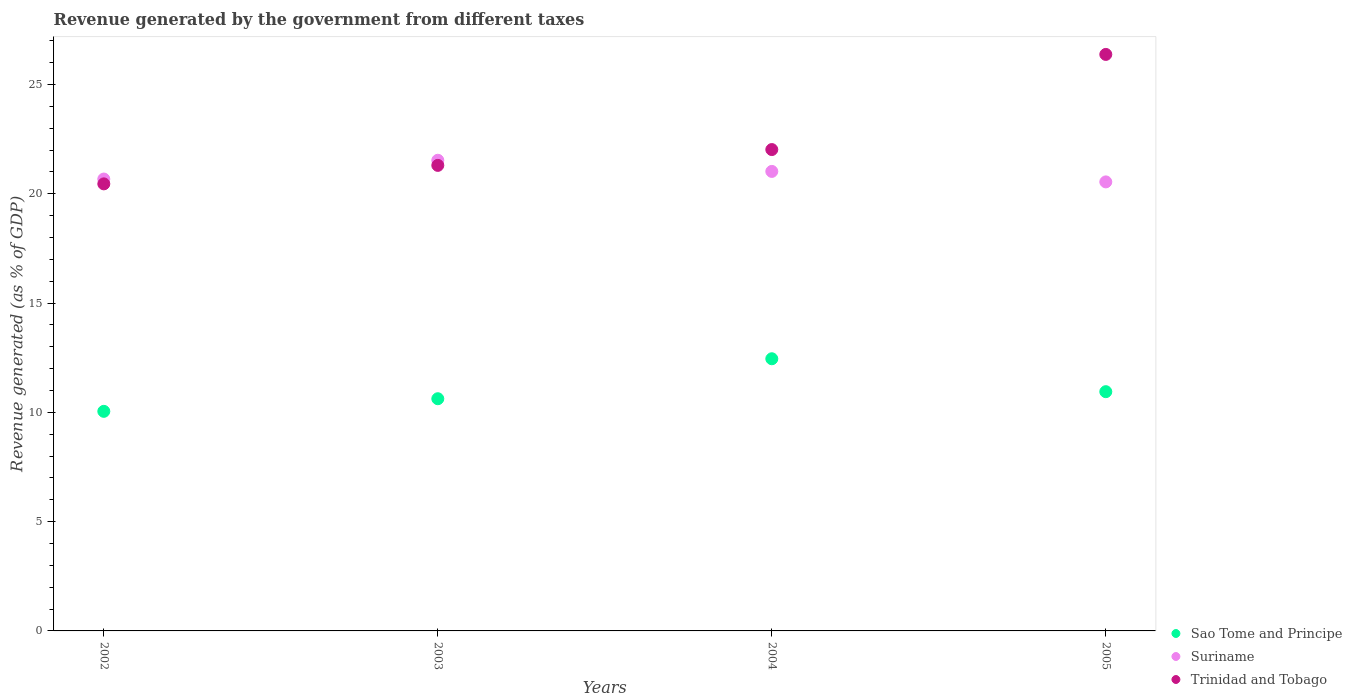How many different coloured dotlines are there?
Your answer should be very brief. 3. What is the revenue generated by the government in Suriname in 2002?
Provide a succinct answer. 20.68. Across all years, what is the maximum revenue generated by the government in Trinidad and Tobago?
Keep it short and to the point. 26.38. Across all years, what is the minimum revenue generated by the government in Trinidad and Tobago?
Your answer should be compact. 20.46. In which year was the revenue generated by the government in Sao Tome and Principe maximum?
Offer a very short reply. 2004. In which year was the revenue generated by the government in Suriname minimum?
Your answer should be very brief. 2005. What is the total revenue generated by the government in Sao Tome and Principe in the graph?
Your response must be concise. 44.07. What is the difference between the revenue generated by the government in Suriname in 2002 and that in 2003?
Keep it short and to the point. -0.86. What is the difference between the revenue generated by the government in Trinidad and Tobago in 2004 and the revenue generated by the government in Sao Tome and Principe in 2005?
Offer a terse response. 11.08. What is the average revenue generated by the government in Sao Tome and Principe per year?
Keep it short and to the point. 11.02. In the year 2004, what is the difference between the revenue generated by the government in Suriname and revenue generated by the government in Trinidad and Tobago?
Your response must be concise. -1. In how many years, is the revenue generated by the government in Suriname greater than 18 %?
Your response must be concise. 4. What is the ratio of the revenue generated by the government in Sao Tome and Principe in 2002 to that in 2004?
Your answer should be very brief. 0.81. Is the revenue generated by the government in Suriname in 2003 less than that in 2004?
Offer a terse response. No. Is the difference between the revenue generated by the government in Suriname in 2002 and 2003 greater than the difference between the revenue generated by the government in Trinidad and Tobago in 2002 and 2003?
Provide a succinct answer. No. What is the difference between the highest and the second highest revenue generated by the government in Trinidad and Tobago?
Offer a very short reply. 4.35. What is the difference between the highest and the lowest revenue generated by the government in Trinidad and Tobago?
Your answer should be very brief. 5.92. Is the sum of the revenue generated by the government in Suriname in 2003 and 2004 greater than the maximum revenue generated by the government in Sao Tome and Principe across all years?
Provide a succinct answer. Yes. Is it the case that in every year, the sum of the revenue generated by the government in Sao Tome and Principe and revenue generated by the government in Trinidad and Tobago  is greater than the revenue generated by the government in Suriname?
Make the answer very short. Yes. Is the revenue generated by the government in Trinidad and Tobago strictly greater than the revenue generated by the government in Sao Tome and Principe over the years?
Provide a succinct answer. Yes. Is the revenue generated by the government in Suriname strictly less than the revenue generated by the government in Trinidad and Tobago over the years?
Provide a short and direct response. No. Does the graph contain any zero values?
Provide a short and direct response. No. Where does the legend appear in the graph?
Offer a terse response. Bottom right. How many legend labels are there?
Provide a short and direct response. 3. How are the legend labels stacked?
Make the answer very short. Vertical. What is the title of the graph?
Provide a succinct answer. Revenue generated by the government from different taxes. What is the label or title of the Y-axis?
Your answer should be compact. Revenue generated (as % of GDP). What is the Revenue generated (as % of GDP) of Sao Tome and Principe in 2002?
Keep it short and to the point. 10.05. What is the Revenue generated (as % of GDP) of Suriname in 2002?
Make the answer very short. 20.68. What is the Revenue generated (as % of GDP) in Trinidad and Tobago in 2002?
Keep it short and to the point. 20.46. What is the Revenue generated (as % of GDP) of Sao Tome and Principe in 2003?
Ensure brevity in your answer.  10.62. What is the Revenue generated (as % of GDP) of Suriname in 2003?
Keep it short and to the point. 21.54. What is the Revenue generated (as % of GDP) in Trinidad and Tobago in 2003?
Offer a very short reply. 21.3. What is the Revenue generated (as % of GDP) of Sao Tome and Principe in 2004?
Your response must be concise. 12.45. What is the Revenue generated (as % of GDP) in Suriname in 2004?
Your answer should be compact. 21.03. What is the Revenue generated (as % of GDP) of Trinidad and Tobago in 2004?
Your response must be concise. 22.03. What is the Revenue generated (as % of GDP) in Sao Tome and Principe in 2005?
Your response must be concise. 10.95. What is the Revenue generated (as % of GDP) of Suriname in 2005?
Provide a succinct answer. 20.55. What is the Revenue generated (as % of GDP) in Trinidad and Tobago in 2005?
Provide a short and direct response. 26.38. Across all years, what is the maximum Revenue generated (as % of GDP) in Sao Tome and Principe?
Your response must be concise. 12.45. Across all years, what is the maximum Revenue generated (as % of GDP) in Suriname?
Provide a short and direct response. 21.54. Across all years, what is the maximum Revenue generated (as % of GDP) in Trinidad and Tobago?
Ensure brevity in your answer.  26.38. Across all years, what is the minimum Revenue generated (as % of GDP) in Sao Tome and Principe?
Give a very brief answer. 10.05. Across all years, what is the minimum Revenue generated (as % of GDP) of Suriname?
Make the answer very short. 20.55. Across all years, what is the minimum Revenue generated (as % of GDP) of Trinidad and Tobago?
Provide a succinct answer. 20.46. What is the total Revenue generated (as % of GDP) in Sao Tome and Principe in the graph?
Offer a terse response. 44.07. What is the total Revenue generated (as % of GDP) in Suriname in the graph?
Keep it short and to the point. 83.78. What is the total Revenue generated (as % of GDP) of Trinidad and Tobago in the graph?
Ensure brevity in your answer.  90.16. What is the difference between the Revenue generated (as % of GDP) of Sao Tome and Principe in 2002 and that in 2003?
Make the answer very short. -0.58. What is the difference between the Revenue generated (as % of GDP) of Suriname in 2002 and that in 2003?
Provide a succinct answer. -0.86. What is the difference between the Revenue generated (as % of GDP) of Trinidad and Tobago in 2002 and that in 2003?
Make the answer very short. -0.85. What is the difference between the Revenue generated (as % of GDP) of Sao Tome and Principe in 2002 and that in 2004?
Ensure brevity in your answer.  -2.41. What is the difference between the Revenue generated (as % of GDP) in Suriname in 2002 and that in 2004?
Provide a short and direct response. -0.35. What is the difference between the Revenue generated (as % of GDP) of Trinidad and Tobago in 2002 and that in 2004?
Your answer should be compact. -1.57. What is the difference between the Revenue generated (as % of GDP) in Sao Tome and Principe in 2002 and that in 2005?
Your response must be concise. -0.9. What is the difference between the Revenue generated (as % of GDP) in Suriname in 2002 and that in 2005?
Offer a terse response. 0.13. What is the difference between the Revenue generated (as % of GDP) of Trinidad and Tobago in 2002 and that in 2005?
Keep it short and to the point. -5.92. What is the difference between the Revenue generated (as % of GDP) of Sao Tome and Principe in 2003 and that in 2004?
Provide a short and direct response. -1.83. What is the difference between the Revenue generated (as % of GDP) in Suriname in 2003 and that in 2004?
Offer a very short reply. 0.51. What is the difference between the Revenue generated (as % of GDP) of Trinidad and Tobago in 2003 and that in 2004?
Provide a succinct answer. -0.72. What is the difference between the Revenue generated (as % of GDP) of Sao Tome and Principe in 2003 and that in 2005?
Your answer should be compact. -0.32. What is the difference between the Revenue generated (as % of GDP) in Suriname in 2003 and that in 2005?
Offer a very short reply. 0.99. What is the difference between the Revenue generated (as % of GDP) of Trinidad and Tobago in 2003 and that in 2005?
Your response must be concise. -5.08. What is the difference between the Revenue generated (as % of GDP) in Sao Tome and Principe in 2004 and that in 2005?
Make the answer very short. 1.51. What is the difference between the Revenue generated (as % of GDP) of Suriname in 2004 and that in 2005?
Make the answer very short. 0.48. What is the difference between the Revenue generated (as % of GDP) of Trinidad and Tobago in 2004 and that in 2005?
Make the answer very short. -4.35. What is the difference between the Revenue generated (as % of GDP) in Sao Tome and Principe in 2002 and the Revenue generated (as % of GDP) in Suriname in 2003?
Provide a short and direct response. -11.49. What is the difference between the Revenue generated (as % of GDP) of Sao Tome and Principe in 2002 and the Revenue generated (as % of GDP) of Trinidad and Tobago in 2003?
Your response must be concise. -11.25. What is the difference between the Revenue generated (as % of GDP) of Suriname in 2002 and the Revenue generated (as % of GDP) of Trinidad and Tobago in 2003?
Your answer should be compact. -0.62. What is the difference between the Revenue generated (as % of GDP) in Sao Tome and Principe in 2002 and the Revenue generated (as % of GDP) in Suriname in 2004?
Provide a short and direct response. -10.98. What is the difference between the Revenue generated (as % of GDP) in Sao Tome and Principe in 2002 and the Revenue generated (as % of GDP) in Trinidad and Tobago in 2004?
Ensure brevity in your answer.  -11.98. What is the difference between the Revenue generated (as % of GDP) in Suriname in 2002 and the Revenue generated (as % of GDP) in Trinidad and Tobago in 2004?
Provide a succinct answer. -1.35. What is the difference between the Revenue generated (as % of GDP) in Sao Tome and Principe in 2002 and the Revenue generated (as % of GDP) in Suriname in 2005?
Ensure brevity in your answer.  -10.5. What is the difference between the Revenue generated (as % of GDP) of Sao Tome and Principe in 2002 and the Revenue generated (as % of GDP) of Trinidad and Tobago in 2005?
Your response must be concise. -16.33. What is the difference between the Revenue generated (as % of GDP) in Suriname in 2002 and the Revenue generated (as % of GDP) in Trinidad and Tobago in 2005?
Provide a short and direct response. -5.7. What is the difference between the Revenue generated (as % of GDP) of Sao Tome and Principe in 2003 and the Revenue generated (as % of GDP) of Suriname in 2004?
Provide a short and direct response. -10.4. What is the difference between the Revenue generated (as % of GDP) of Sao Tome and Principe in 2003 and the Revenue generated (as % of GDP) of Trinidad and Tobago in 2004?
Your answer should be very brief. -11.4. What is the difference between the Revenue generated (as % of GDP) in Suriname in 2003 and the Revenue generated (as % of GDP) in Trinidad and Tobago in 2004?
Offer a terse response. -0.49. What is the difference between the Revenue generated (as % of GDP) of Sao Tome and Principe in 2003 and the Revenue generated (as % of GDP) of Suriname in 2005?
Provide a succinct answer. -9.92. What is the difference between the Revenue generated (as % of GDP) of Sao Tome and Principe in 2003 and the Revenue generated (as % of GDP) of Trinidad and Tobago in 2005?
Ensure brevity in your answer.  -15.75. What is the difference between the Revenue generated (as % of GDP) of Suriname in 2003 and the Revenue generated (as % of GDP) of Trinidad and Tobago in 2005?
Provide a succinct answer. -4.84. What is the difference between the Revenue generated (as % of GDP) in Sao Tome and Principe in 2004 and the Revenue generated (as % of GDP) in Suriname in 2005?
Your answer should be compact. -8.09. What is the difference between the Revenue generated (as % of GDP) of Sao Tome and Principe in 2004 and the Revenue generated (as % of GDP) of Trinidad and Tobago in 2005?
Offer a terse response. -13.93. What is the difference between the Revenue generated (as % of GDP) of Suriname in 2004 and the Revenue generated (as % of GDP) of Trinidad and Tobago in 2005?
Ensure brevity in your answer.  -5.35. What is the average Revenue generated (as % of GDP) of Sao Tome and Principe per year?
Keep it short and to the point. 11.02. What is the average Revenue generated (as % of GDP) of Suriname per year?
Offer a very short reply. 20.95. What is the average Revenue generated (as % of GDP) of Trinidad and Tobago per year?
Make the answer very short. 22.54. In the year 2002, what is the difference between the Revenue generated (as % of GDP) of Sao Tome and Principe and Revenue generated (as % of GDP) of Suriname?
Offer a very short reply. -10.63. In the year 2002, what is the difference between the Revenue generated (as % of GDP) of Sao Tome and Principe and Revenue generated (as % of GDP) of Trinidad and Tobago?
Make the answer very short. -10.41. In the year 2002, what is the difference between the Revenue generated (as % of GDP) of Suriname and Revenue generated (as % of GDP) of Trinidad and Tobago?
Give a very brief answer. 0.22. In the year 2003, what is the difference between the Revenue generated (as % of GDP) in Sao Tome and Principe and Revenue generated (as % of GDP) in Suriname?
Your answer should be very brief. -10.91. In the year 2003, what is the difference between the Revenue generated (as % of GDP) of Sao Tome and Principe and Revenue generated (as % of GDP) of Trinidad and Tobago?
Offer a very short reply. -10.68. In the year 2003, what is the difference between the Revenue generated (as % of GDP) of Suriname and Revenue generated (as % of GDP) of Trinidad and Tobago?
Your response must be concise. 0.23. In the year 2004, what is the difference between the Revenue generated (as % of GDP) of Sao Tome and Principe and Revenue generated (as % of GDP) of Suriname?
Your response must be concise. -8.57. In the year 2004, what is the difference between the Revenue generated (as % of GDP) of Sao Tome and Principe and Revenue generated (as % of GDP) of Trinidad and Tobago?
Ensure brevity in your answer.  -9.57. In the year 2004, what is the difference between the Revenue generated (as % of GDP) in Suriname and Revenue generated (as % of GDP) in Trinidad and Tobago?
Provide a short and direct response. -1. In the year 2005, what is the difference between the Revenue generated (as % of GDP) in Sao Tome and Principe and Revenue generated (as % of GDP) in Suriname?
Provide a succinct answer. -9.6. In the year 2005, what is the difference between the Revenue generated (as % of GDP) of Sao Tome and Principe and Revenue generated (as % of GDP) of Trinidad and Tobago?
Offer a terse response. -15.43. In the year 2005, what is the difference between the Revenue generated (as % of GDP) of Suriname and Revenue generated (as % of GDP) of Trinidad and Tobago?
Ensure brevity in your answer.  -5.83. What is the ratio of the Revenue generated (as % of GDP) of Sao Tome and Principe in 2002 to that in 2003?
Provide a short and direct response. 0.95. What is the ratio of the Revenue generated (as % of GDP) of Suriname in 2002 to that in 2003?
Ensure brevity in your answer.  0.96. What is the ratio of the Revenue generated (as % of GDP) of Trinidad and Tobago in 2002 to that in 2003?
Keep it short and to the point. 0.96. What is the ratio of the Revenue generated (as % of GDP) of Sao Tome and Principe in 2002 to that in 2004?
Your answer should be compact. 0.81. What is the ratio of the Revenue generated (as % of GDP) of Suriname in 2002 to that in 2004?
Ensure brevity in your answer.  0.98. What is the ratio of the Revenue generated (as % of GDP) of Trinidad and Tobago in 2002 to that in 2004?
Make the answer very short. 0.93. What is the ratio of the Revenue generated (as % of GDP) in Sao Tome and Principe in 2002 to that in 2005?
Your answer should be very brief. 0.92. What is the ratio of the Revenue generated (as % of GDP) of Suriname in 2002 to that in 2005?
Provide a succinct answer. 1.01. What is the ratio of the Revenue generated (as % of GDP) in Trinidad and Tobago in 2002 to that in 2005?
Your answer should be compact. 0.78. What is the ratio of the Revenue generated (as % of GDP) in Sao Tome and Principe in 2003 to that in 2004?
Provide a short and direct response. 0.85. What is the ratio of the Revenue generated (as % of GDP) in Suriname in 2003 to that in 2004?
Your answer should be very brief. 1.02. What is the ratio of the Revenue generated (as % of GDP) of Trinidad and Tobago in 2003 to that in 2004?
Make the answer very short. 0.97. What is the ratio of the Revenue generated (as % of GDP) of Sao Tome and Principe in 2003 to that in 2005?
Your answer should be compact. 0.97. What is the ratio of the Revenue generated (as % of GDP) of Suriname in 2003 to that in 2005?
Offer a very short reply. 1.05. What is the ratio of the Revenue generated (as % of GDP) of Trinidad and Tobago in 2003 to that in 2005?
Make the answer very short. 0.81. What is the ratio of the Revenue generated (as % of GDP) of Sao Tome and Principe in 2004 to that in 2005?
Keep it short and to the point. 1.14. What is the ratio of the Revenue generated (as % of GDP) in Suriname in 2004 to that in 2005?
Your response must be concise. 1.02. What is the ratio of the Revenue generated (as % of GDP) in Trinidad and Tobago in 2004 to that in 2005?
Offer a very short reply. 0.83. What is the difference between the highest and the second highest Revenue generated (as % of GDP) in Sao Tome and Principe?
Your response must be concise. 1.51. What is the difference between the highest and the second highest Revenue generated (as % of GDP) in Suriname?
Keep it short and to the point. 0.51. What is the difference between the highest and the second highest Revenue generated (as % of GDP) of Trinidad and Tobago?
Ensure brevity in your answer.  4.35. What is the difference between the highest and the lowest Revenue generated (as % of GDP) of Sao Tome and Principe?
Keep it short and to the point. 2.41. What is the difference between the highest and the lowest Revenue generated (as % of GDP) in Suriname?
Give a very brief answer. 0.99. What is the difference between the highest and the lowest Revenue generated (as % of GDP) of Trinidad and Tobago?
Give a very brief answer. 5.92. 